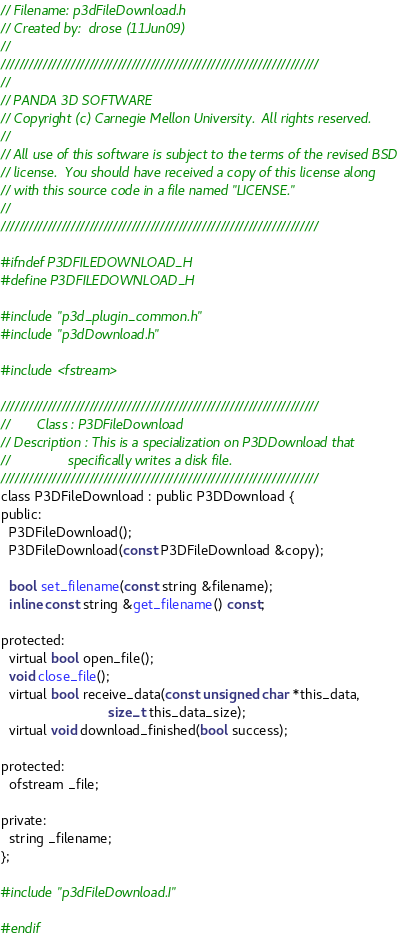<code> <loc_0><loc_0><loc_500><loc_500><_C_>// Filename: p3dFileDownload.h
// Created by:  drose (11Jun09)
//
////////////////////////////////////////////////////////////////////
//
// PANDA 3D SOFTWARE
// Copyright (c) Carnegie Mellon University.  All rights reserved.
//
// All use of this software is subject to the terms of the revised BSD
// license.  You should have received a copy of this license along
// with this source code in a file named "LICENSE."
//
////////////////////////////////////////////////////////////////////

#ifndef P3DFILEDOWNLOAD_H
#define P3DFILEDOWNLOAD_H

#include "p3d_plugin_common.h"
#include "p3dDownload.h"

#include <fstream>

////////////////////////////////////////////////////////////////////
//       Class : P3DFileDownload
// Description : This is a specialization on P3DDownload that
//               specifically writes a disk file.
////////////////////////////////////////////////////////////////////
class P3DFileDownload : public P3DDownload {
public:
  P3DFileDownload();
  P3DFileDownload(const P3DFileDownload &copy);

  bool set_filename(const string &filename);
  inline const string &get_filename() const;

protected:
  virtual bool open_file();
  void close_file();
  virtual bool receive_data(const unsigned char *this_data,
                            size_t this_data_size);
  virtual void download_finished(bool success);

protected:
  ofstream _file;

private:
  string _filename;
};

#include "p3dFileDownload.I"

#endif
</code> 